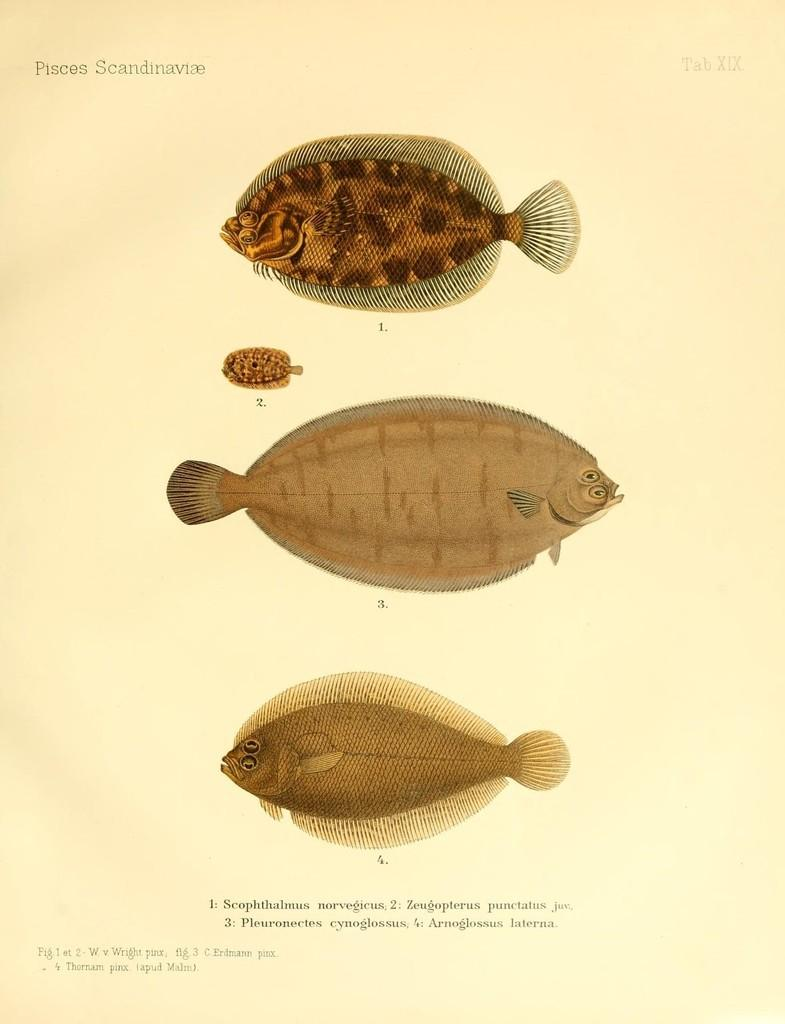What type of animals can be seen in the image? There are fishes in the image. Is there any text present in the image? Yes, there is text written at the bottom of the image. What type of school can be seen in the image? There is no school present in the image; it features fishes and text. Is there a beggar visible in the image? There is no beggar present in the image. 